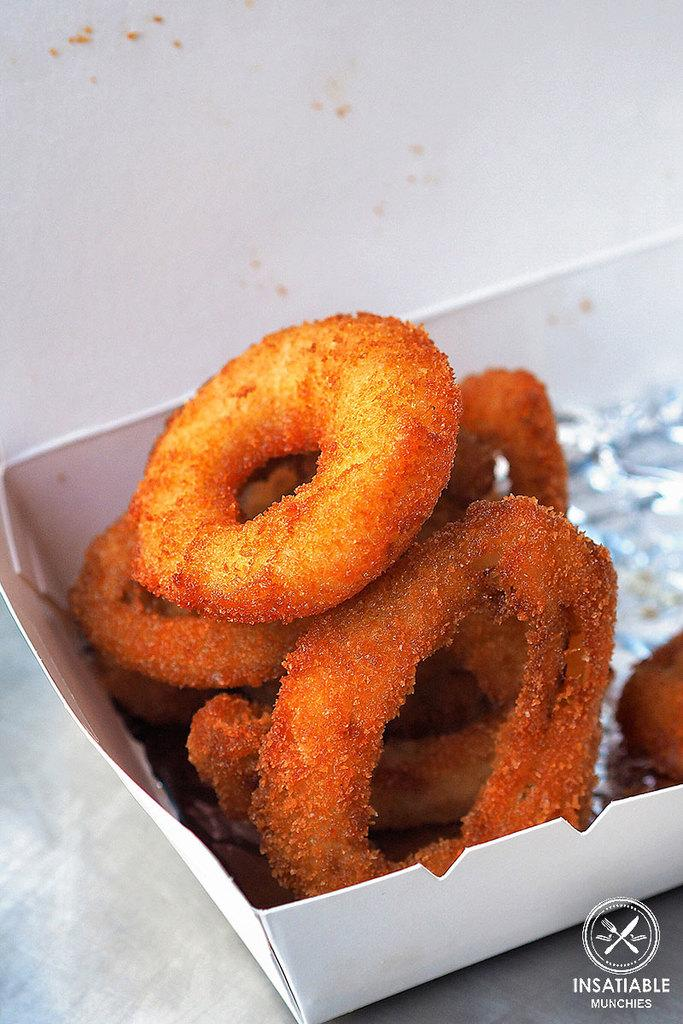What type of container holds the food items in the image? The food items are in a paper bowl. Can you describe the food items in the image? Unfortunately, the specific food items cannot be determined from the provided facts. How much payment is required for the tree in the image? There is no tree present in the image, so the question of payment is not applicable. 